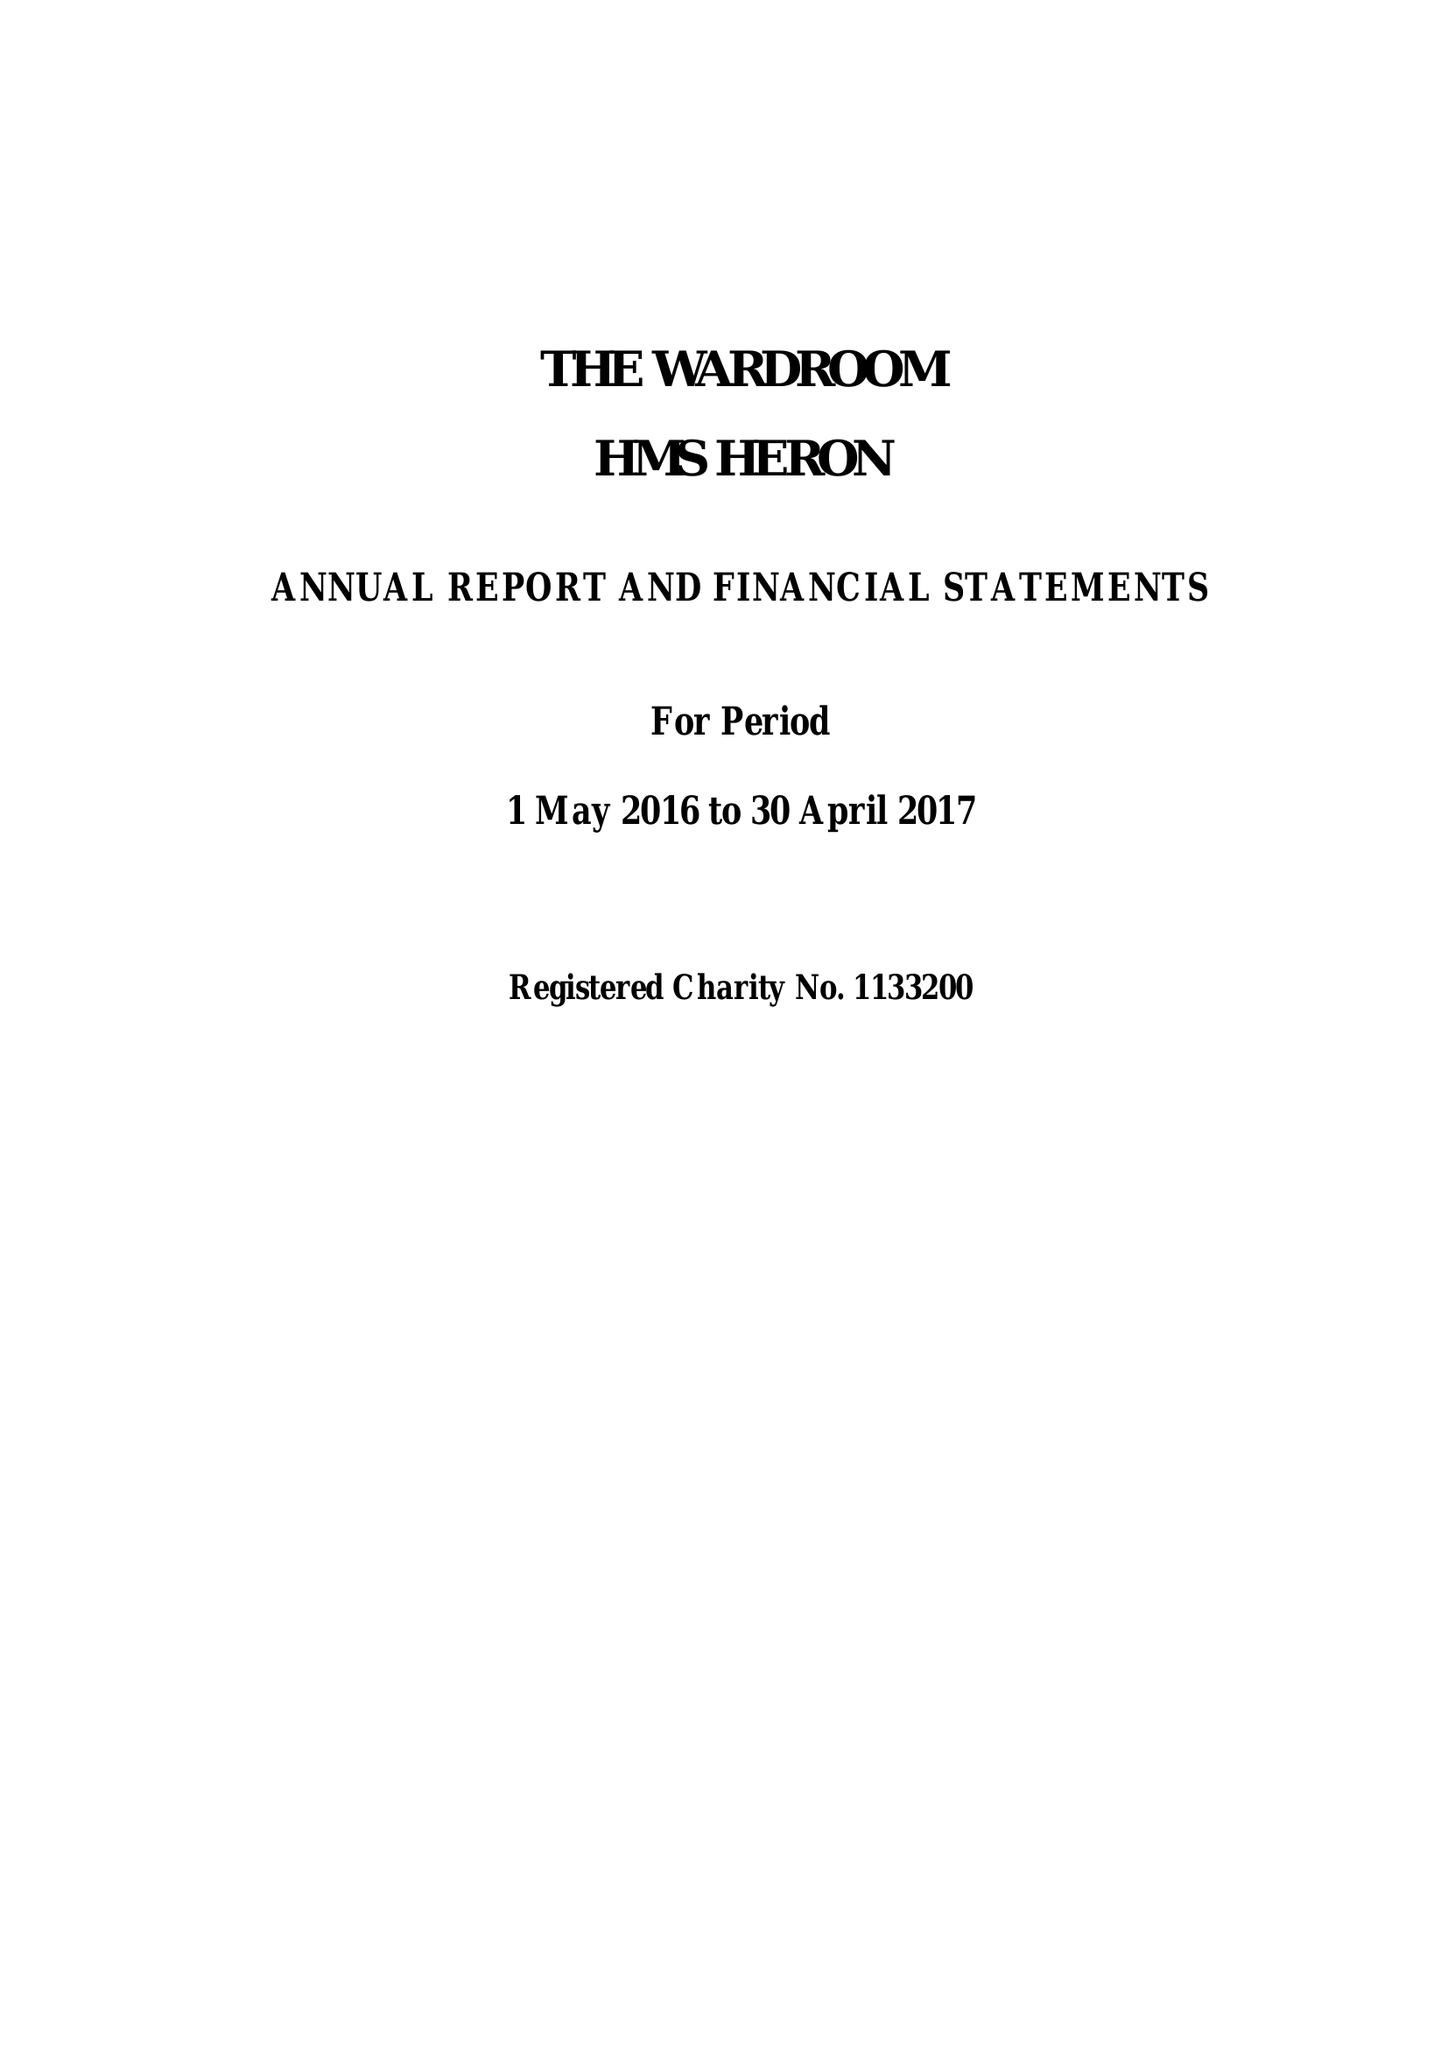What is the value for the address__post_town?
Answer the question using a single word or phrase. YEOVIL 